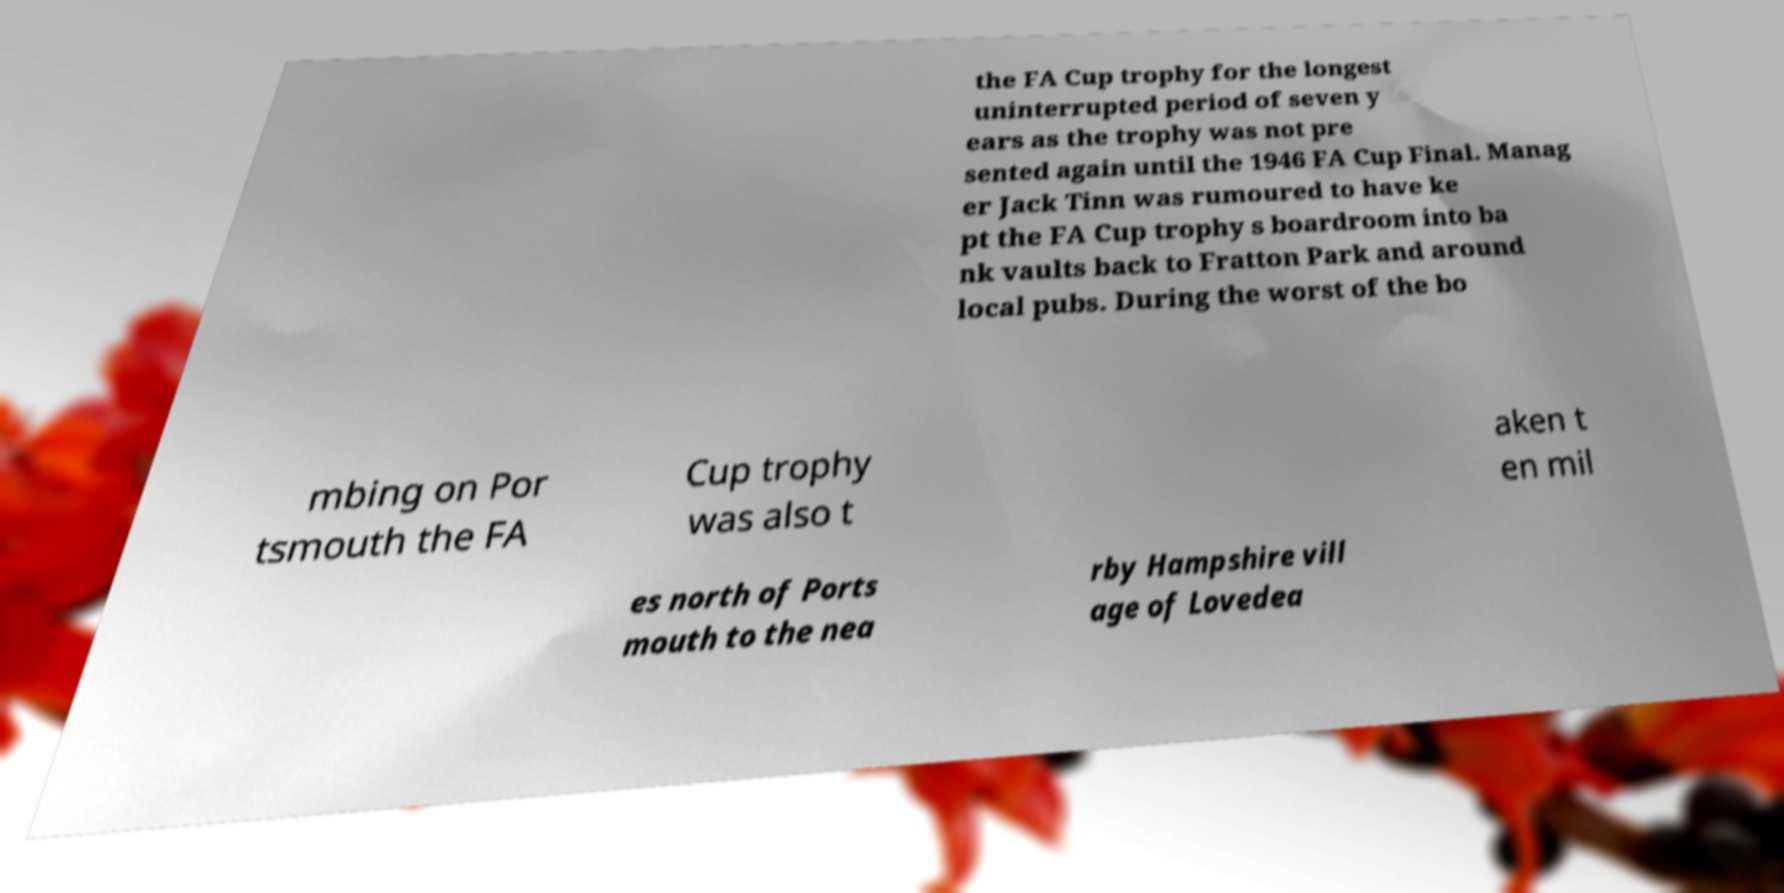Can you read and provide the text displayed in the image?This photo seems to have some interesting text. Can you extract and type it out for me? the FA Cup trophy for the longest uninterrupted period of seven y ears as the trophy was not pre sented again until the 1946 FA Cup Final. Manag er Jack Tinn was rumoured to have ke pt the FA Cup trophy s boardroom into ba nk vaults back to Fratton Park and around local pubs. During the worst of the bo mbing on Por tsmouth the FA Cup trophy was also t aken t en mil es north of Ports mouth to the nea rby Hampshire vill age of Lovedea 